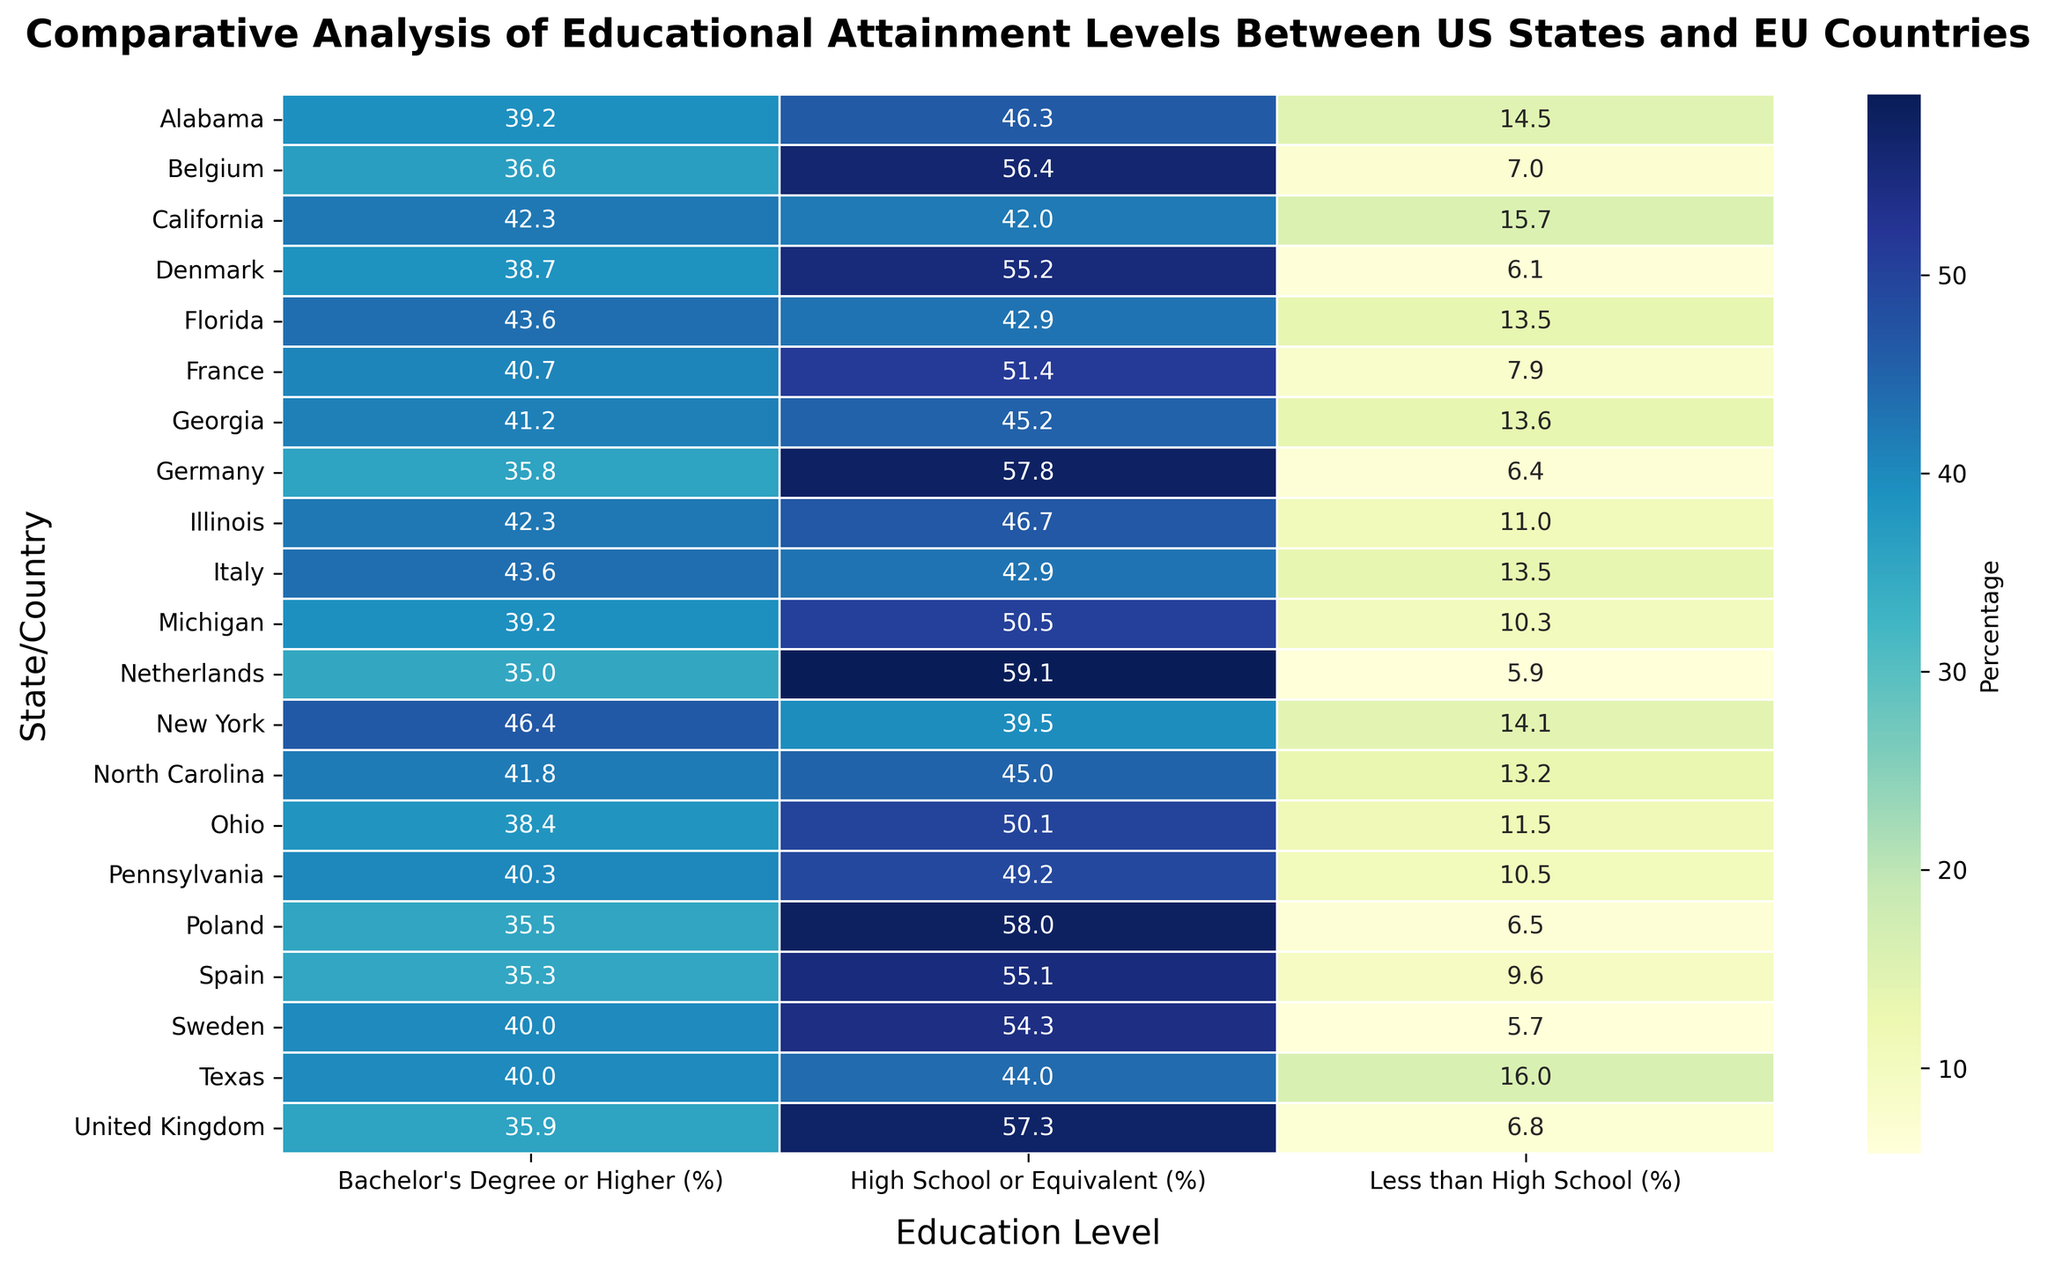Which state/country has the highest percentage of individuals with a Bachelor's Degree or Higher? Look at the column 'Bachelor's Degree or Higher (%).' Identify the highest percentage value and the corresponding state/country. It is New York with 46.4%.
Answer: New York Which state has the lowest percentage of individuals with Less than High School education? Look at the 'Less than High School (%)' column. Identify the lowest percentage value and the corresponding state. It is Michigan with 10.3%.
Answer: Michigan Compare the percentage of individuals with High School or Equivalent education in the United Kingdom and Germany. Which country has a higher value? Look at the 'High School or Equivalent (%)' values for the United Kingdom and Germany. The United Kingdom has 57.3%, and Germany has 57.8%. Thus, Germany has a higher value.
Answer: Germany Which EU country has the highest percentage of individuals with a Bachelor’s Degree or Higher? Look at the column 'Bachelor's Degree or Higher (%)' for the EU countries. Identify the highest percentage value and the corresponding country. It is France with 40.7%.
Answer: France What is the average percentage of individuals with Less than High School education across all US states? Add up all the percentages in the 'Less than High School (%)' column for US states and divide by the number of US states. (15.7 + 16 + 14.1 + 13.5 + 11.5 + 11 + 10.5 + 13.6 + 10.3 + 13.2 + 14.5) / 11 = 12.95%
Answer: 12.95% Between Ohio and Sweden, which has a higher percentage of individuals with High School or Equivalent education? Compare the 'High School or Equivalent (%)' values for Ohio (50.1%) and Sweden (54.3%). Sweden has a higher value.
Answer: Sweden Find the state/country with the smallest difference between the percentages of individuals with Less than High School and Bachelor's Degree or Higher education. Calculate the absolute difference for each state/country. The smallest difference is in Netherlands: abs(5.9 - 35.0) = 29.1. Netherlands
Answer: Netherlands Which US state has the highest percentage of individuals with High School or Equivalent education? Look at the 'High School or Equivalent (%)' column for the US states. Identify the highest percentage value, which is Michigan with 50.5%.
Answer: Michigan 